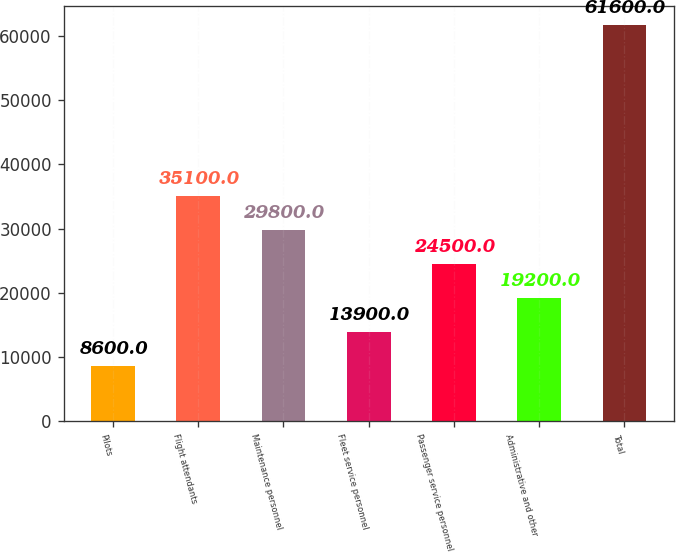Convert chart. <chart><loc_0><loc_0><loc_500><loc_500><bar_chart><fcel>Pilots<fcel>Flight attendants<fcel>Maintenance personnel<fcel>Fleet service personnel<fcel>Passenger service personnel<fcel>Administrative and other<fcel>Total<nl><fcel>8600<fcel>35100<fcel>29800<fcel>13900<fcel>24500<fcel>19200<fcel>61600<nl></chart> 